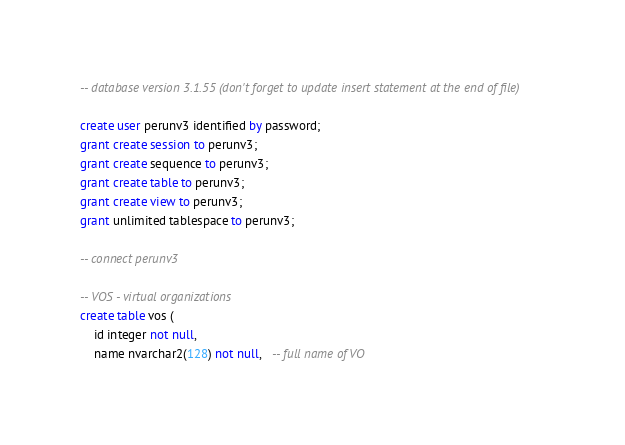<code> <loc_0><loc_0><loc_500><loc_500><_SQL_>-- database version 3.1.55 (don't forget to update insert statement at the end of file)

create user perunv3 identified by password;
grant create session to perunv3;
grant create sequence to perunv3;
grant create table to perunv3;
grant create view to perunv3;
grant unlimited tablespace to perunv3;

-- connect perunv3

-- VOS - virtual organizations
create table vos (
	id integer not null,
	name nvarchar2(128) not null,   -- full name of VO</code> 